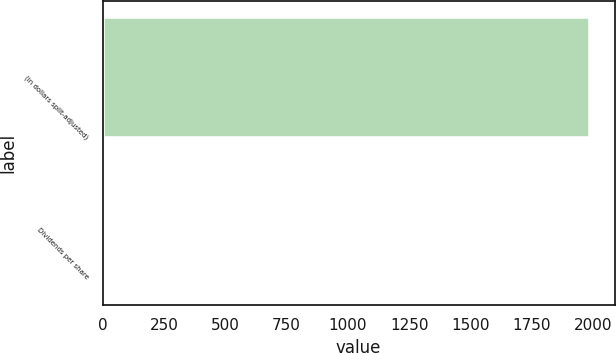<chart> <loc_0><loc_0><loc_500><loc_500><bar_chart><fcel>(in dollars split-adjusted)<fcel>Dividends per share<nl><fcel>1989<fcel>0.19<nl></chart> 